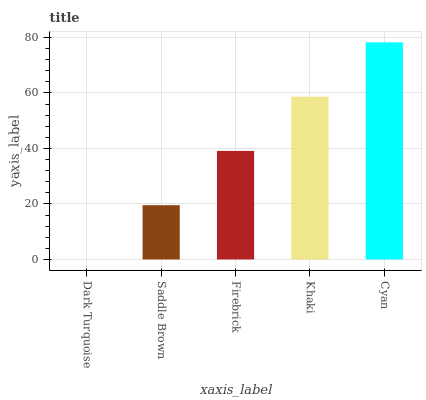Is Dark Turquoise the minimum?
Answer yes or no. Yes. Is Cyan the maximum?
Answer yes or no. Yes. Is Saddle Brown the minimum?
Answer yes or no. No. Is Saddle Brown the maximum?
Answer yes or no. No. Is Saddle Brown greater than Dark Turquoise?
Answer yes or no. Yes. Is Dark Turquoise less than Saddle Brown?
Answer yes or no. Yes. Is Dark Turquoise greater than Saddle Brown?
Answer yes or no. No. Is Saddle Brown less than Dark Turquoise?
Answer yes or no. No. Is Firebrick the high median?
Answer yes or no. Yes. Is Firebrick the low median?
Answer yes or no. Yes. Is Dark Turquoise the high median?
Answer yes or no. No. Is Khaki the low median?
Answer yes or no. No. 